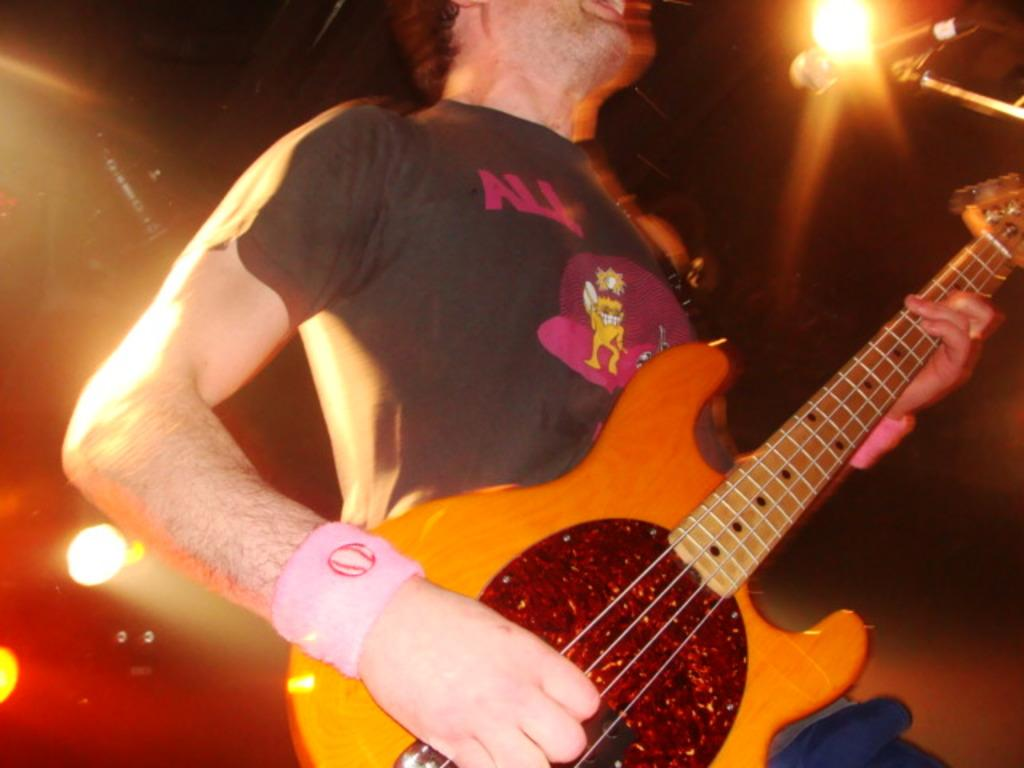Who is the main subject in the image? There is a man in the image. What is the man doing in the image? The man is playing a guitar. What object is the man standing in front of? The man is standing in front of a mic. How many cherries are on the guitar in the image? There are no cherries present in the image, and the guitar is not mentioned as having any cherries on it. 